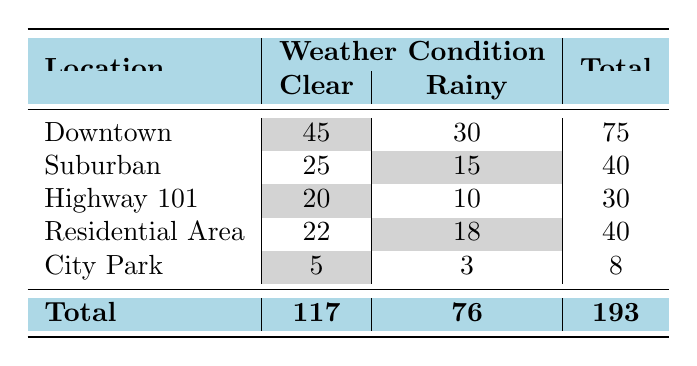What is the total number of traffic violations in Downtown? In the table, the total violation count for Downtown is the sum of its Clear and Rainy weather conditions. The count for Clear is 45, and for Rainy, it's 30. Therefore, the total is 45 + 30 = 75.
Answer: 75 What is the total count of traffic violations when the weather is Clear? To find the total count of violations during Clear weather, we need to add the counts for each location under the Clear condition: 45 (Downtown) + 25 (Suburban) + 20 (Highway 101) + 22 (Residential Area) + 5 (City Park) = 117.
Answer: 117 Are there more traffic violations in Rainy weather than in Clear weather? We compare the total counts of traffic violations in both weather conditions. The table shows 76 violations for Rainy and 117 for Clear. Since 76 is less than 117, the answer is no.
Answer: No Which location had the highest number of traffic violations in Rainy weather? We look through the Rainy weather counts in the table: Downtown has 30, Suburban has 15, Highway 101 has 10, Residential Area has 18, and City Park has 3. The highest value is 30, which is from Downtown.
Answer: Downtown What is the difference in violation counts for Clear and Rainy weather in the Residential Area? The violation count for Residential Area under Clear weather is 22, and for Rainy weather, it is 18. The difference is calculated as 22 - 18 = 4.
Answer: 4 How many locations have a higher violation count in Clear weather than in Rainy weather? We analyze the counts in the table for each location. Downtown (45 > 30), Suburban (25 > 15), Highway 101 (20 > 10), Residential Area (22 > 18), and City Park (5 > 3) all have higher counts in Clear weather. That's 5 locations total.
Answer: 5 Is the total number of traffic violations exactly twice as many during Clear weather compared to City Park? For City Park, the total violations are 5 (Clear) and 3 (Rainy), making a total of 8. Twice this total would be 16. For Clear weather, the total is 117. Since 117 is not equal to 16, the answer is no.
Answer: No What is the average number of traffic violations for all locations during Rainy weather? We sum the violations during Rainy weather: 30 (Downtown) + 15 (Suburban) + 10 (Highway 101) + 18 (Residential Area) + 3 (City Park) = 76. There are 5 locations, so the average is 76 / 5 = 15.2.
Answer: 15.2 